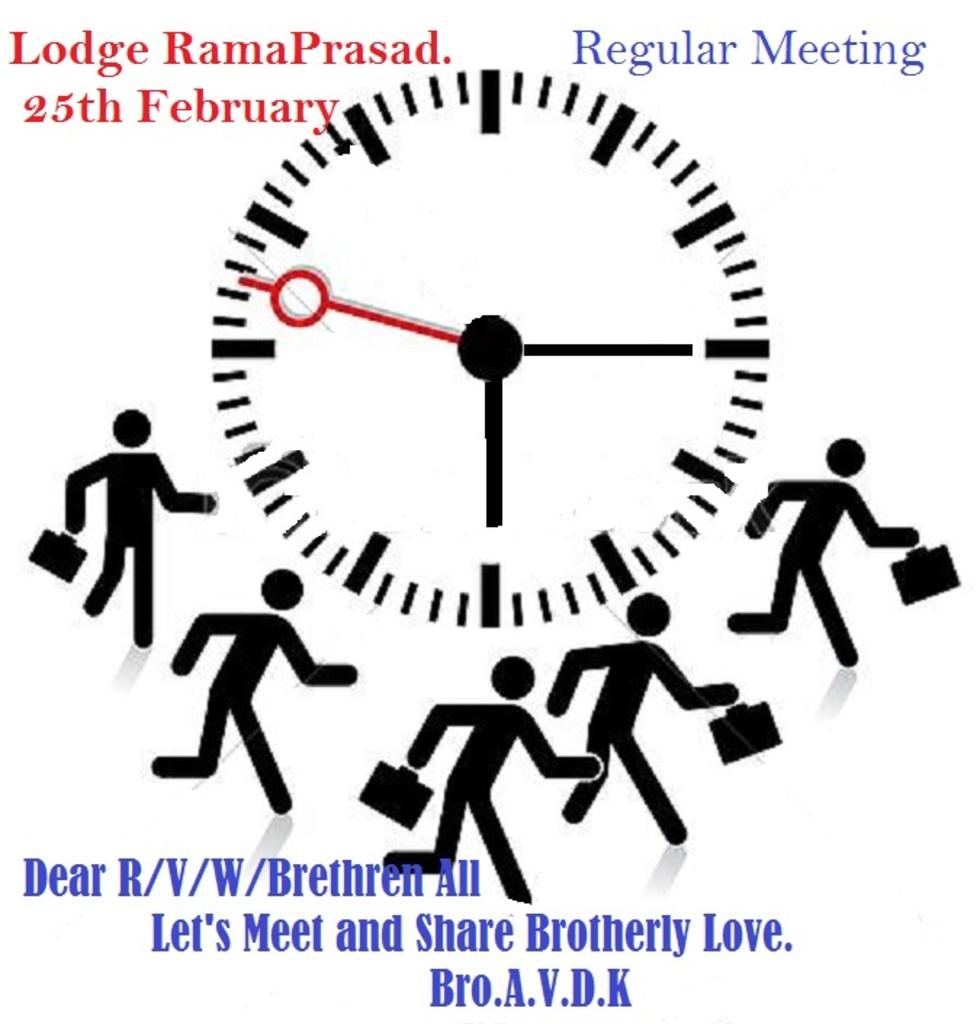<image>
Offer a succinct explanation of the picture presented. A graphic which mentions the 25th of February. 